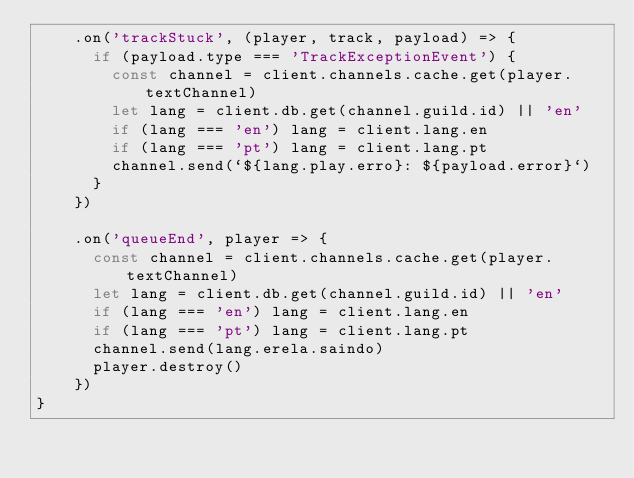<code> <loc_0><loc_0><loc_500><loc_500><_JavaScript_>    .on('trackStuck', (player, track, payload) => {
      if (payload.type === 'TrackExceptionEvent') {
        const channel = client.channels.cache.get(player.textChannel)
        let lang = client.db.get(channel.guild.id) || 'en'
        if (lang === 'en') lang = client.lang.en
        if (lang === 'pt') lang = client.lang.pt
        channel.send(`${lang.play.erro}: ${payload.error}`)
      }
    })

    .on('queueEnd', player => {
      const channel = client.channels.cache.get(player.textChannel)
      let lang = client.db.get(channel.guild.id) || 'en'
      if (lang === 'en') lang = client.lang.en
      if (lang === 'pt') lang = client.lang.pt
      channel.send(lang.erela.saindo)
      player.destroy()
    })
}
</code> 